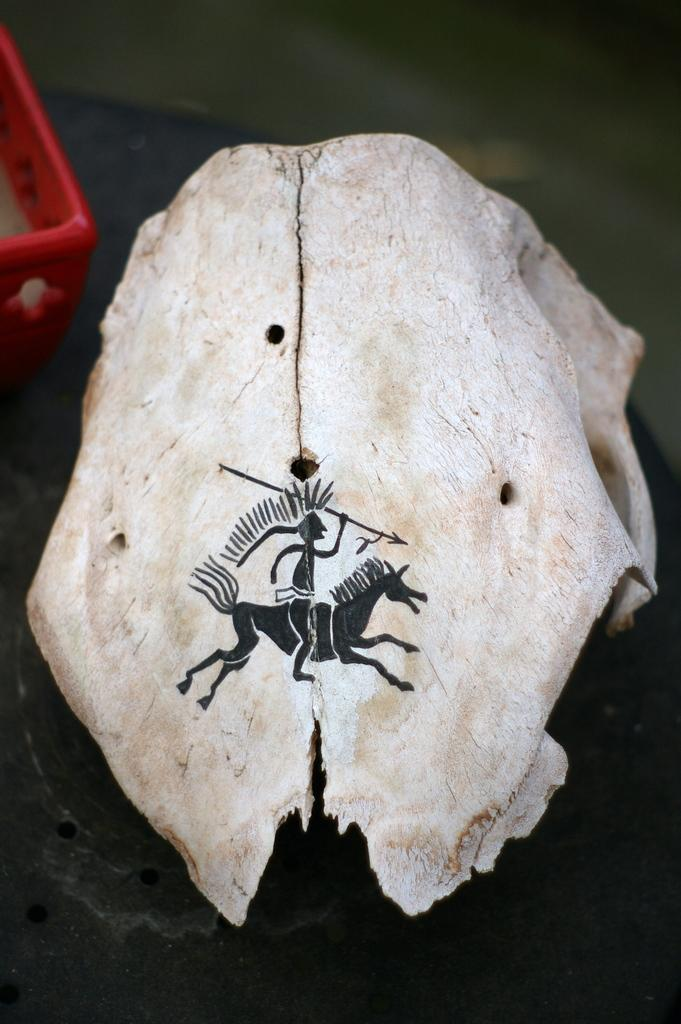What is the main subject of the image? The main subject of the image is an animal skull. What is the animal skull resting on? The animal skull is on a black object. Are there any additional features on the animal skull? Yes, there is a painting on the animal skull. What can be seen on the left side of the skull? There is a red tray on the left side of the skull. Can you see a frog sitting on the animal skull in the image? No, there is no frog present in the image. 